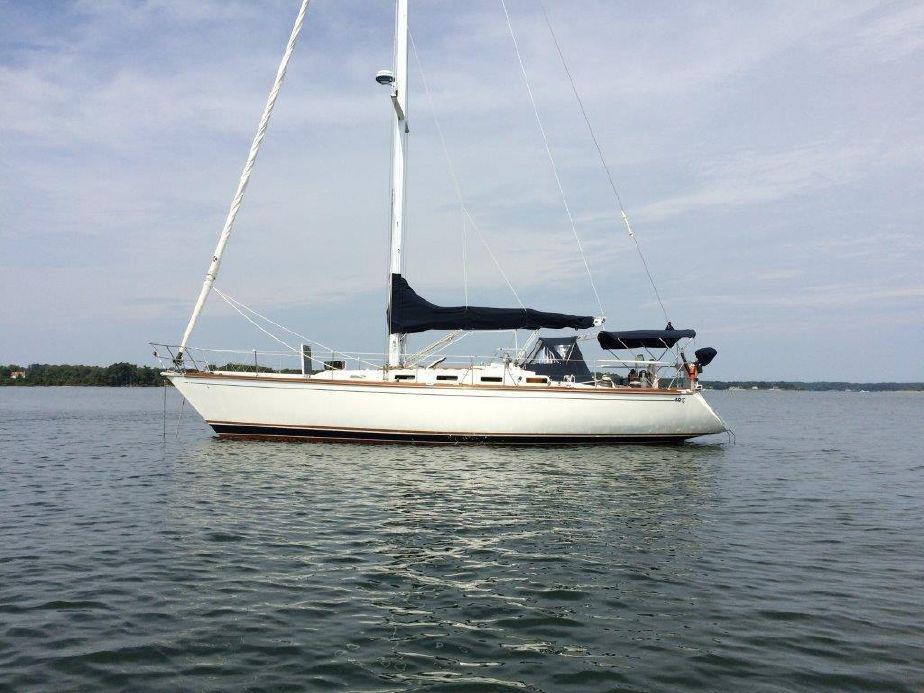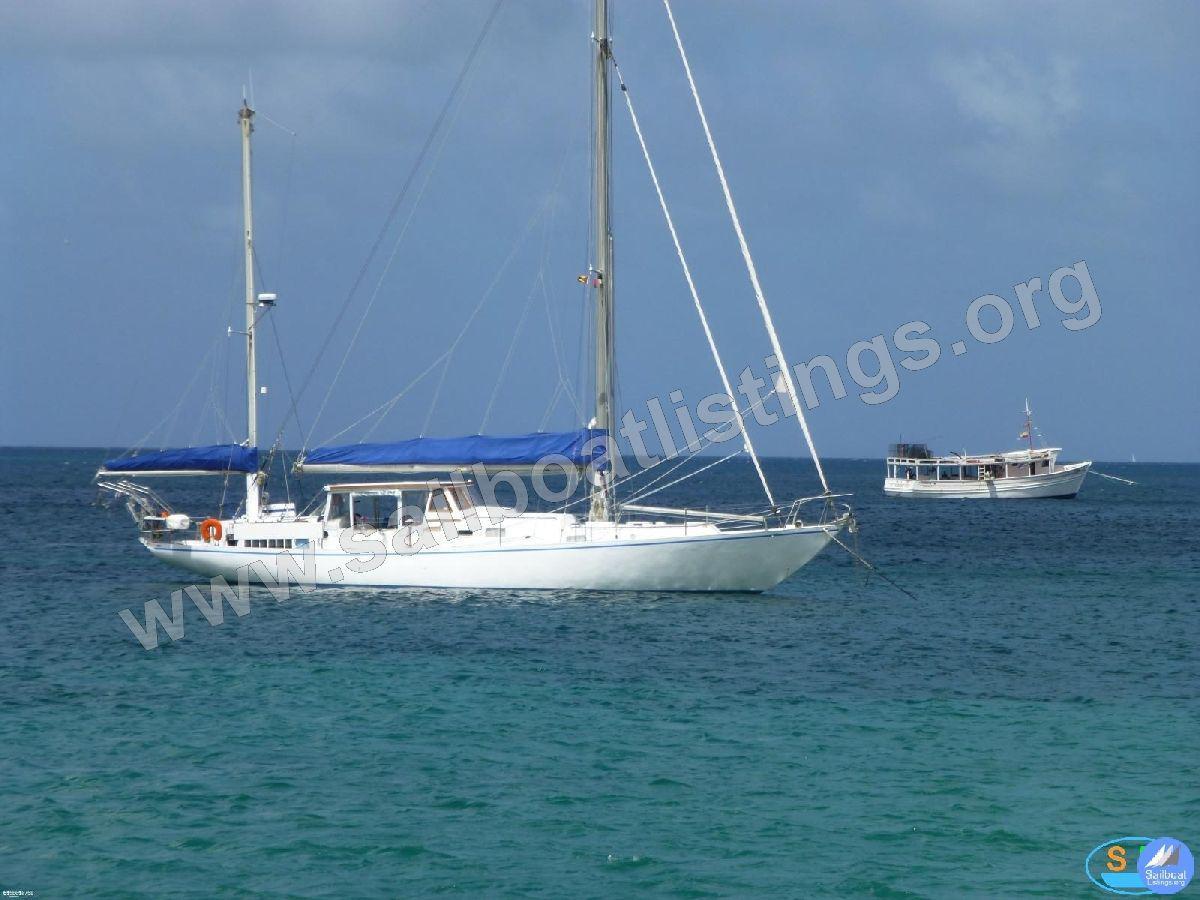The first image is the image on the left, the second image is the image on the right. For the images displayed, is the sentence "The left and right image contains a total of three boats." factually correct? Answer yes or no. Yes. The first image is the image on the left, the second image is the image on the right. Considering the images on both sides, is "One boat with a rider in a red jacket creates white spray as it moves through water with unfurled sails, while the other boat is still and has furled sails." valid? Answer yes or no. No. 